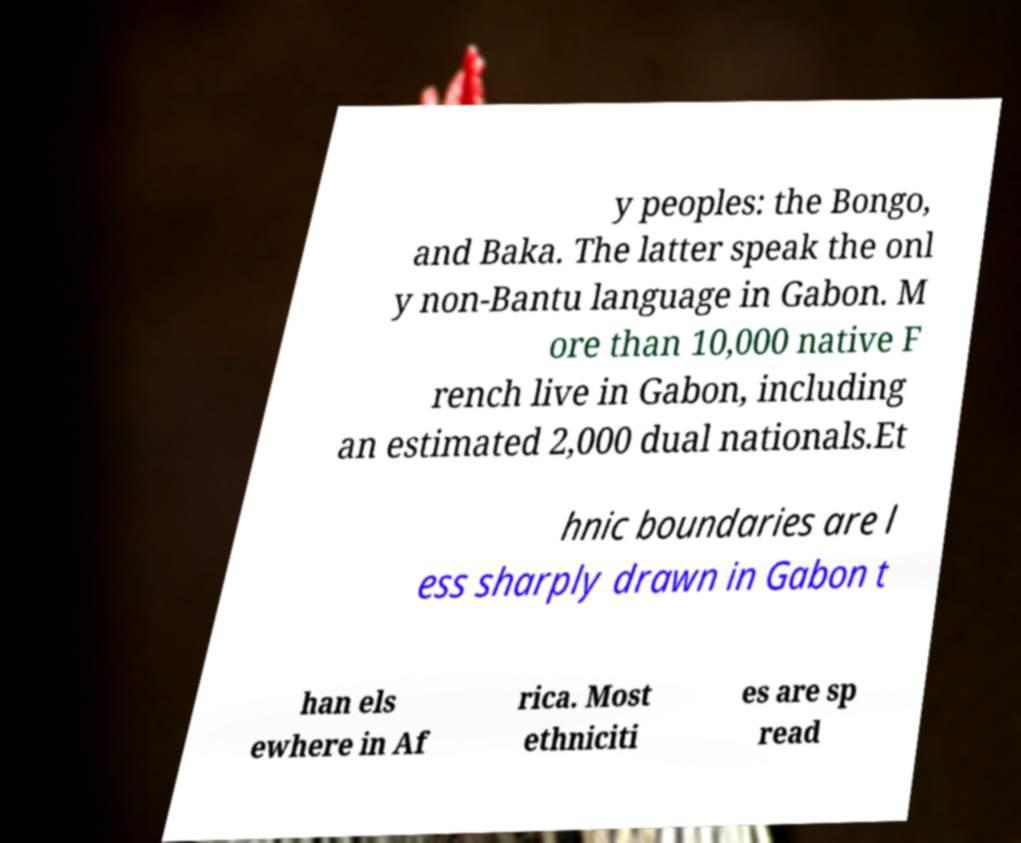Can you accurately transcribe the text from the provided image for me? y peoples: the Bongo, and Baka. The latter speak the onl y non-Bantu language in Gabon. M ore than 10,000 native F rench live in Gabon, including an estimated 2,000 dual nationals.Et hnic boundaries are l ess sharply drawn in Gabon t han els ewhere in Af rica. Most ethniciti es are sp read 